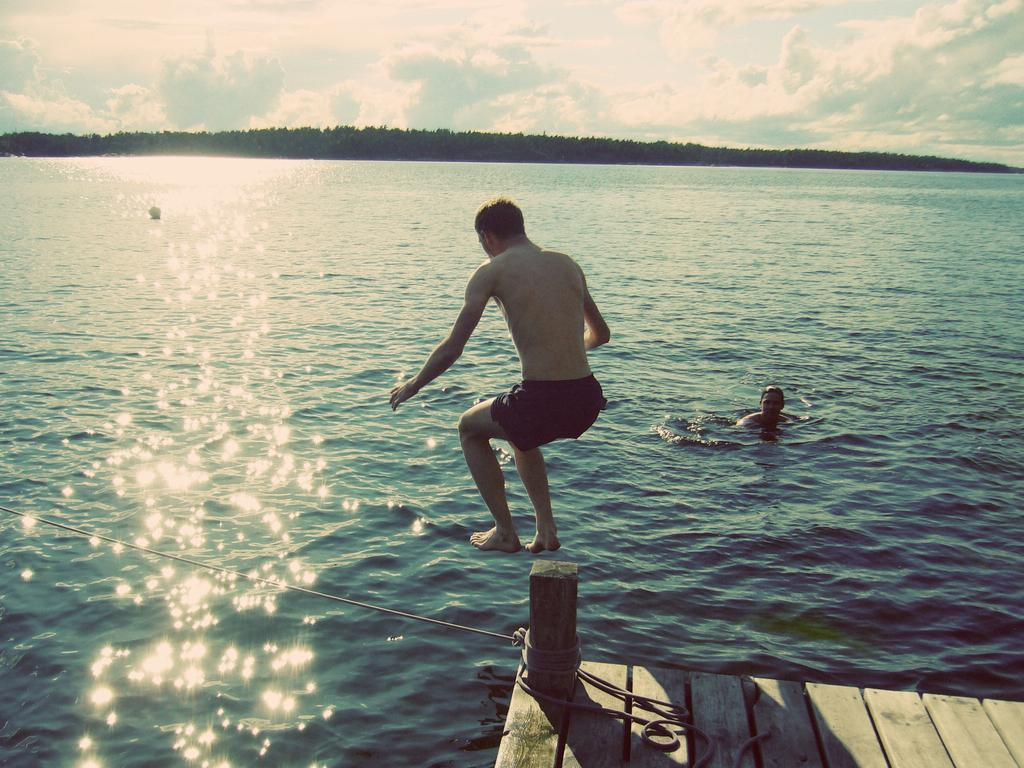What is on the wooden platform in the image? There is a rope on a wooden platform in the image. How many people are in the image? There are two men in the image. What is the position of one of the men in the image? One man is in the water. What action is being performed by a person in the image? A person is jumping in the image. What can be seen in the background of the image? There is sky visible in the background of the image. What type of weather can be inferred from the image? Clouds are present in the sky, suggesting a partly cloudy day. What type of cherry is being used as a prop in the image? There is no cherry present in the image. How many rabbits can be seen in the image? There are no rabbits present in the image. 